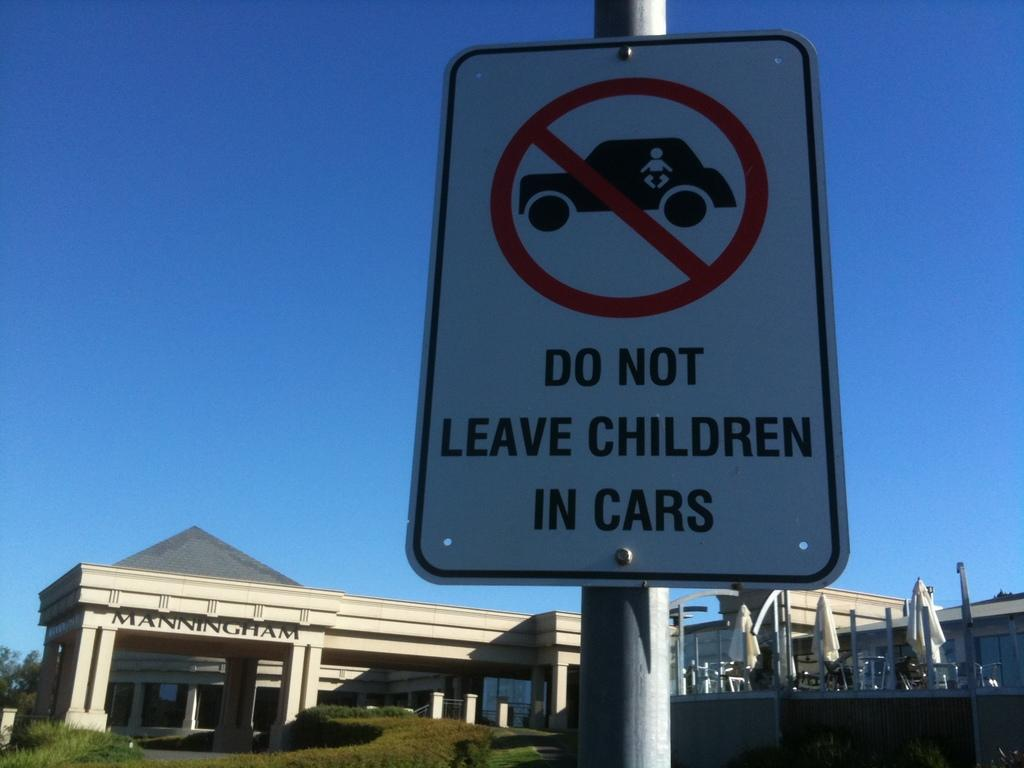<image>
Render a clear and concise summary of the photo. A sign in front of Manningham building reading "Do not leave children in cars" 